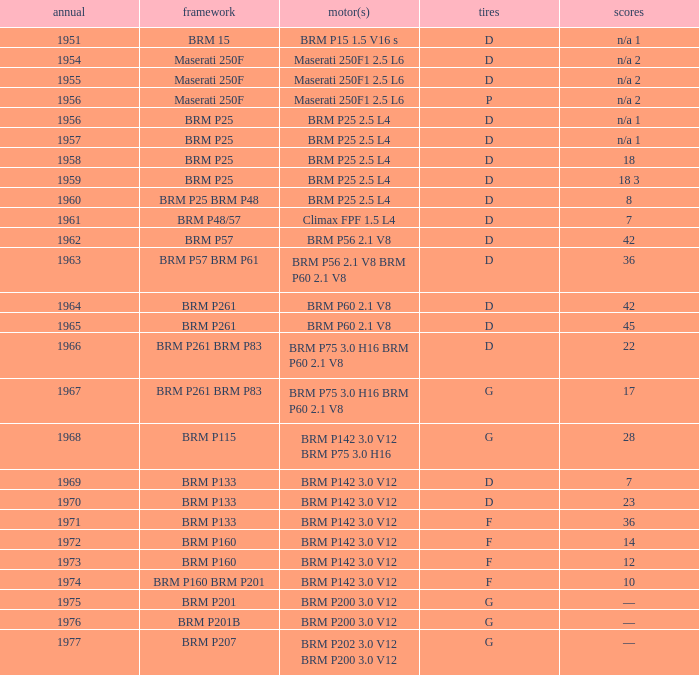Name the chassis of 1961 BRM P48/57. 